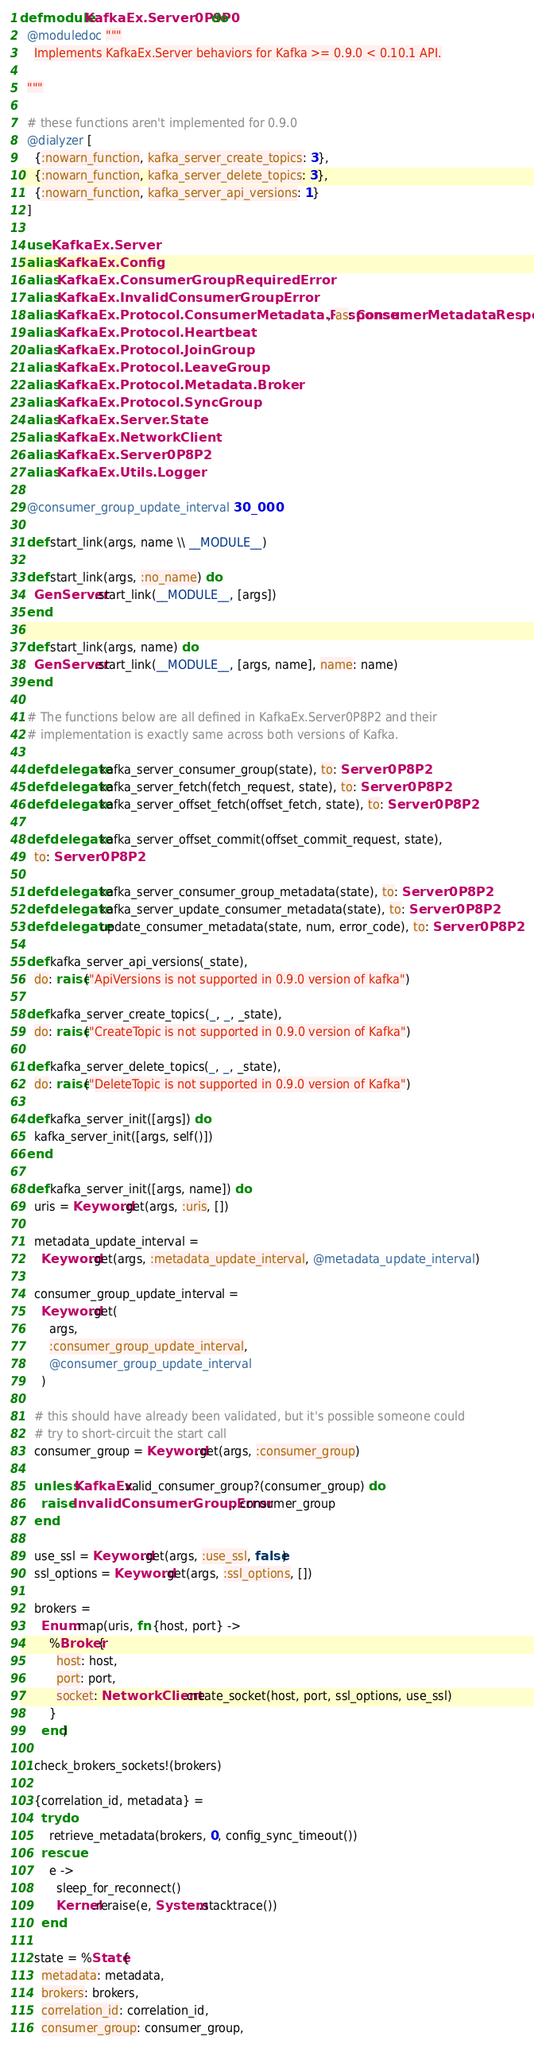Convert code to text. <code><loc_0><loc_0><loc_500><loc_500><_Elixir_>defmodule KafkaEx.Server0P9P0 do
  @moduledoc """
    Implements KafkaEx.Server behaviors for Kafka >= 0.9.0 < 0.10.1 API.

  """

  # these functions aren't implemented for 0.9.0
  @dialyzer [
    {:nowarn_function, kafka_server_create_topics: 3},
    {:nowarn_function, kafka_server_delete_topics: 3},
    {:nowarn_function, kafka_server_api_versions: 1}
  ]

  use KafkaEx.Server
  alias KafkaEx.Config
  alias KafkaEx.ConsumerGroupRequiredError
  alias KafkaEx.InvalidConsumerGroupError
  alias KafkaEx.Protocol.ConsumerMetadata.Response, as: ConsumerMetadataResponse
  alias KafkaEx.Protocol.Heartbeat
  alias KafkaEx.Protocol.JoinGroup
  alias KafkaEx.Protocol.LeaveGroup
  alias KafkaEx.Protocol.Metadata.Broker
  alias KafkaEx.Protocol.SyncGroup
  alias KafkaEx.Server.State
  alias KafkaEx.NetworkClient
  alias KafkaEx.Server0P8P2
  alias KafkaEx.Utils.Logger

  @consumer_group_update_interval 30_000

  def start_link(args, name \\ __MODULE__)

  def start_link(args, :no_name) do
    GenServer.start_link(__MODULE__, [args])
  end

  def start_link(args, name) do
    GenServer.start_link(__MODULE__, [args, name], name: name)
  end

  # The functions below are all defined in KafkaEx.Server0P8P2 and their
  # implementation is exactly same across both versions of Kafka.

  defdelegate kafka_server_consumer_group(state), to: Server0P8P2
  defdelegate kafka_server_fetch(fetch_request, state), to: Server0P8P2
  defdelegate kafka_server_offset_fetch(offset_fetch, state), to: Server0P8P2

  defdelegate kafka_server_offset_commit(offset_commit_request, state),
    to: Server0P8P2

  defdelegate kafka_server_consumer_group_metadata(state), to: Server0P8P2
  defdelegate kafka_server_update_consumer_metadata(state), to: Server0P8P2
  defdelegate update_consumer_metadata(state, num, error_code), to: Server0P8P2

  def kafka_server_api_versions(_state),
    do: raise("ApiVersions is not supported in 0.9.0 version of kafka")

  def kafka_server_create_topics(_, _, _state),
    do: raise("CreateTopic is not supported in 0.9.0 version of Kafka")

  def kafka_server_delete_topics(_, _, _state),
    do: raise("DeleteTopic is not supported in 0.9.0 version of Kafka")

  def kafka_server_init([args]) do
    kafka_server_init([args, self()])
  end

  def kafka_server_init([args, name]) do
    uris = Keyword.get(args, :uris, [])

    metadata_update_interval =
      Keyword.get(args, :metadata_update_interval, @metadata_update_interval)

    consumer_group_update_interval =
      Keyword.get(
        args,
        :consumer_group_update_interval,
        @consumer_group_update_interval
      )

    # this should have already been validated, but it's possible someone could
    # try to short-circuit the start call
    consumer_group = Keyword.get(args, :consumer_group)

    unless KafkaEx.valid_consumer_group?(consumer_group) do
      raise InvalidConsumerGroupError, consumer_group
    end

    use_ssl = Keyword.get(args, :use_ssl, false)
    ssl_options = Keyword.get(args, :ssl_options, [])

    brokers =
      Enum.map(uris, fn {host, port} ->
        %Broker{
          host: host,
          port: port,
          socket: NetworkClient.create_socket(host, port, ssl_options, use_ssl)
        }
      end)

    check_brokers_sockets!(brokers)

    {correlation_id, metadata} =
      try do
        retrieve_metadata(brokers, 0, config_sync_timeout())
      rescue
        e ->
          sleep_for_reconnect()
          Kernel.reraise(e, System.stacktrace())
      end

    state = %State{
      metadata: metadata,
      brokers: brokers,
      correlation_id: correlation_id,
      consumer_group: consumer_group,</code> 